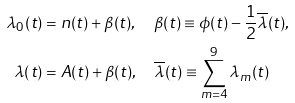Convert formula to latex. <formula><loc_0><loc_0><loc_500><loc_500>\lambda _ { 0 } ( t ) & = n ( t ) + \beta ( t ) , \quad \beta ( t ) \equiv \phi ( t ) - \frac { 1 } { 2 } \overline { \lambda } ( t ) , \\ \lambda ( t ) & = A ( t ) + \beta ( t ) , \quad \overline { \lambda } ( t ) \equiv \sum _ { m = 4 } ^ { 9 } \lambda _ { m } ( t )</formula> 